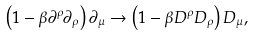<formula> <loc_0><loc_0><loc_500><loc_500>\left ( 1 - \beta \partial ^ { \rho } \partial _ { \rho } \right ) \partial _ { \mu } \rightarrow \left ( { 1 } - \beta D ^ { \rho } D _ { \rho } \right ) D _ { \mu } ,</formula> 